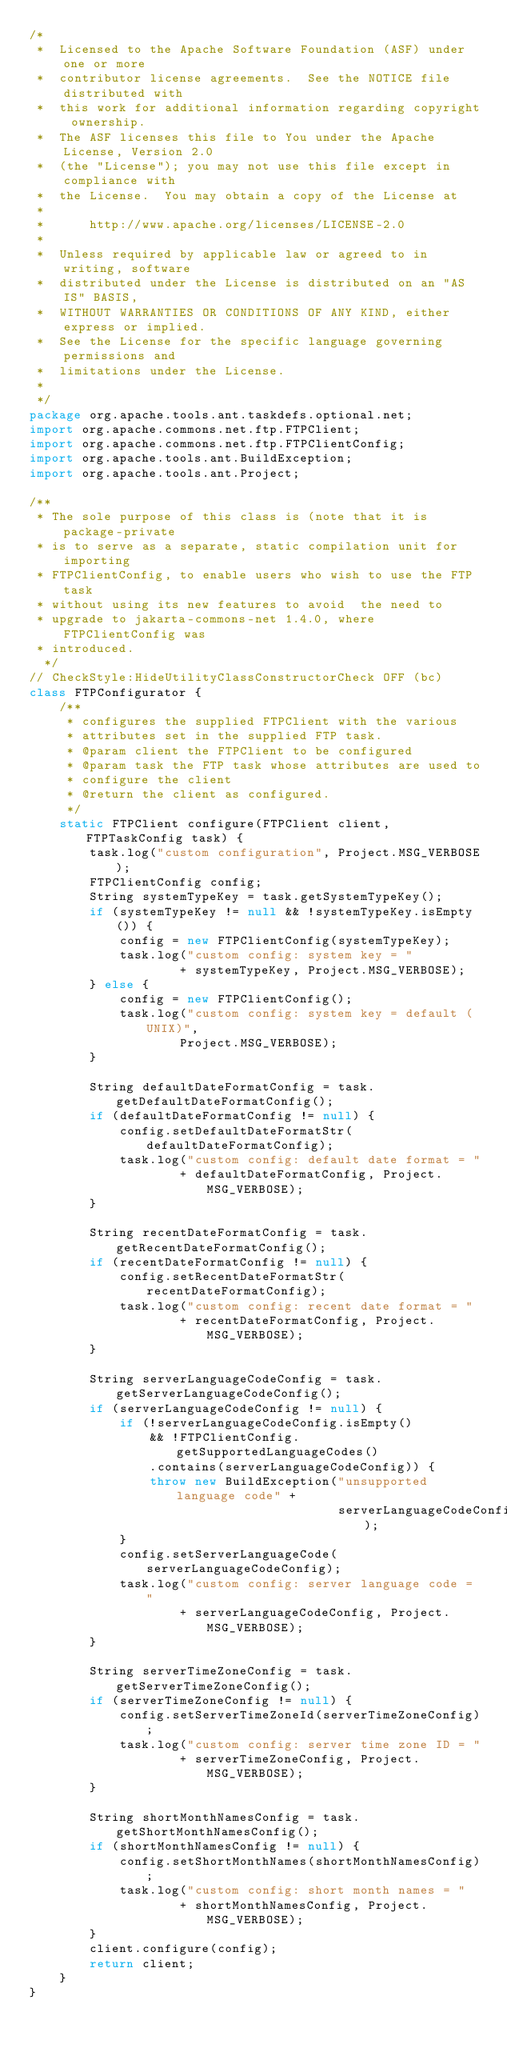<code> <loc_0><loc_0><loc_500><loc_500><_Java_>/*
 *  Licensed to the Apache Software Foundation (ASF) under one or more
 *  contributor license agreements.  See the NOTICE file distributed with
 *  this work for additional information regarding copyright ownership.
 *  The ASF licenses this file to You under the Apache License, Version 2.0
 *  (the "License"); you may not use this file except in compliance with
 *  the License.  You may obtain a copy of the License at
 *
 *      http://www.apache.org/licenses/LICENSE-2.0
 *
 *  Unless required by applicable law or agreed to in writing, software
 *  distributed under the License is distributed on an "AS IS" BASIS,
 *  WITHOUT WARRANTIES OR CONDITIONS OF ANY KIND, either express or implied.
 *  See the License for the specific language governing permissions and
 *  limitations under the License.
 *
 */
package org.apache.tools.ant.taskdefs.optional.net;
import org.apache.commons.net.ftp.FTPClient;
import org.apache.commons.net.ftp.FTPClientConfig;
import org.apache.tools.ant.BuildException;
import org.apache.tools.ant.Project;

/**
 * The sole purpose of this class is (note that it is package-private
 * is to serve as a separate, static compilation unit for importing
 * FTPClientConfig, to enable users who wish to use the FTP task
 * without using its new features to avoid  the need to
 * upgrade to jakarta-commons-net 1.4.0, where FTPClientConfig was
 * introduced.
  */
// CheckStyle:HideUtilityClassConstructorCheck OFF (bc)
class FTPConfigurator {
    /**
     * configures the supplied FTPClient with the various
     * attributes set in the supplied FTP task.
     * @param client the FTPClient to be configured
     * @param task the FTP task whose attributes are used to
     * configure the client
     * @return the client as configured.
     */
    static FTPClient configure(FTPClient client, FTPTaskConfig task) {
        task.log("custom configuration", Project.MSG_VERBOSE);
        FTPClientConfig config;
        String systemTypeKey = task.getSystemTypeKey();
        if (systemTypeKey != null && !systemTypeKey.isEmpty()) {
            config = new FTPClientConfig(systemTypeKey);
            task.log("custom config: system key = "
                    + systemTypeKey, Project.MSG_VERBOSE);
        } else {
            config = new FTPClientConfig();
            task.log("custom config: system key = default (UNIX)",
                    Project.MSG_VERBOSE);
        }

        String defaultDateFormatConfig = task.getDefaultDateFormatConfig();
        if (defaultDateFormatConfig != null) {
            config.setDefaultDateFormatStr(defaultDateFormatConfig);
            task.log("custom config: default date format = "
                    + defaultDateFormatConfig, Project.MSG_VERBOSE);
        }

        String recentDateFormatConfig = task.getRecentDateFormatConfig();
        if (recentDateFormatConfig != null) {
            config.setRecentDateFormatStr(recentDateFormatConfig);
            task.log("custom config: recent date format = "
                    + recentDateFormatConfig, Project.MSG_VERBOSE);
        }

        String serverLanguageCodeConfig = task.getServerLanguageCodeConfig();
        if (serverLanguageCodeConfig != null) {
            if (!serverLanguageCodeConfig.isEmpty()
                && !FTPClientConfig.getSupportedLanguageCodes()
                .contains(serverLanguageCodeConfig)) {
                throw new BuildException("unsupported language code" +
                                         serverLanguageCodeConfig);
            }
            config.setServerLanguageCode(serverLanguageCodeConfig);
            task.log("custom config: server language code = "
                    + serverLanguageCodeConfig, Project.MSG_VERBOSE);
        }

        String serverTimeZoneConfig = task.getServerTimeZoneConfig();
        if (serverTimeZoneConfig != null) {
            config.setServerTimeZoneId(serverTimeZoneConfig);
            task.log("custom config: server time zone ID = "
                    + serverTimeZoneConfig, Project.MSG_VERBOSE);
        }

        String shortMonthNamesConfig = task.getShortMonthNamesConfig();
        if (shortMonthNamesConfig != null) {
            config.setShortMonthNames(shortMonthNamesConfig);
            task.log("custom config: short month names = "
                    + shortMonthNamesConfig, Project.MSG_VERBOSE);
        }
        client.configure(config);
        return client;
    }
}
</code> 